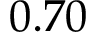Convert formula to latex. <formula><loc_0><loc_0><loc_500><loc_500>0 . 7 0</formula> 